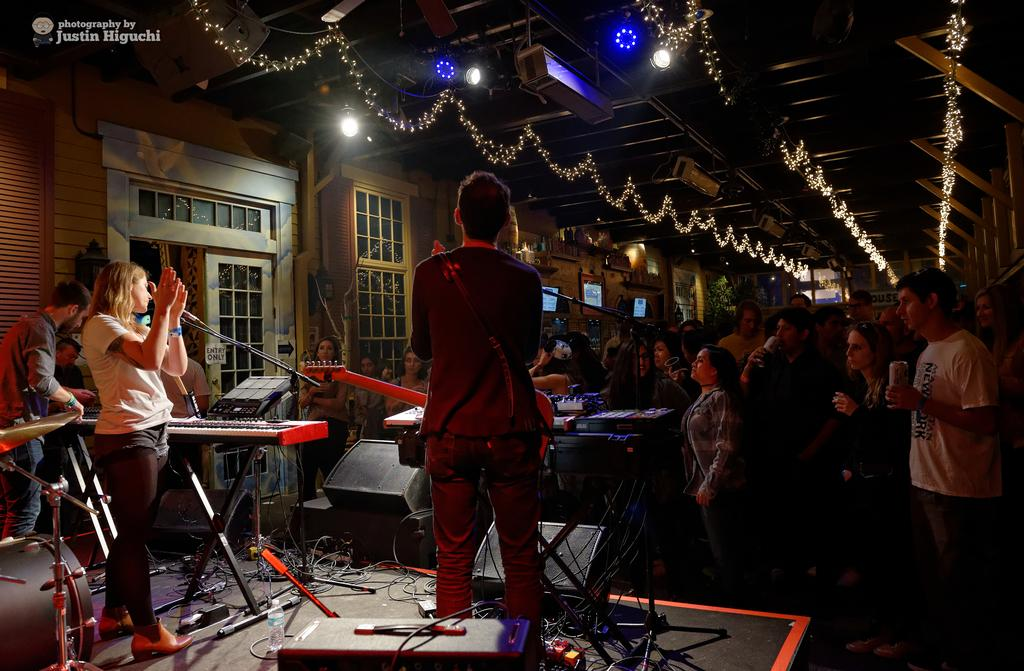What is the main activity being performed by a person in the image? There is a person playing the guitar in the image. What is another person doing in the image? There is a person in front of a microphone in the image. Can you describe the presence of other people in the image? There are other people present in the image. What can be seen on the roof in the image? There are lights on the roof in the image. What type of wilderness can be seen in the background of the image? There is no wilderness visible in the image; it appears to be an indoor setting with lights on the roof. Can you tell me which judge is performing in the image? There is no judge present in the image, only people playing musical instruments and using a microphone. 